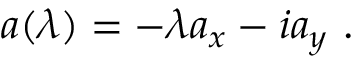Convert formula to latex. <formula><loc_0><loc_0><loc_500><loc_500>a ( \lambda ) = - \lambda a _ { x } - i a _ { y } \ .</formula> 